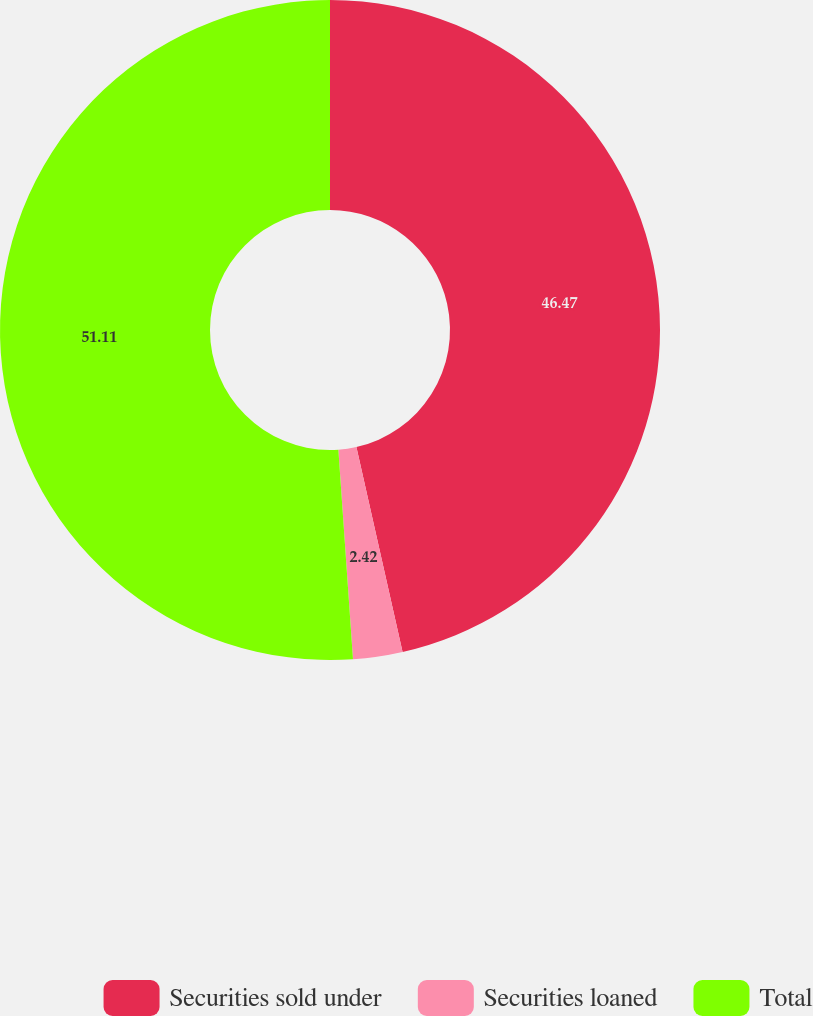Convert chart to OTSL. <chart><loc_0><loc_0><loc_500><loc_500><pie_chart><fcel>Securities sold under<fcel>Securities loaned<fcel>Total<nl><fcel>46.47%<fcel>2.42%<fcel>51.11%<nl></chart> 